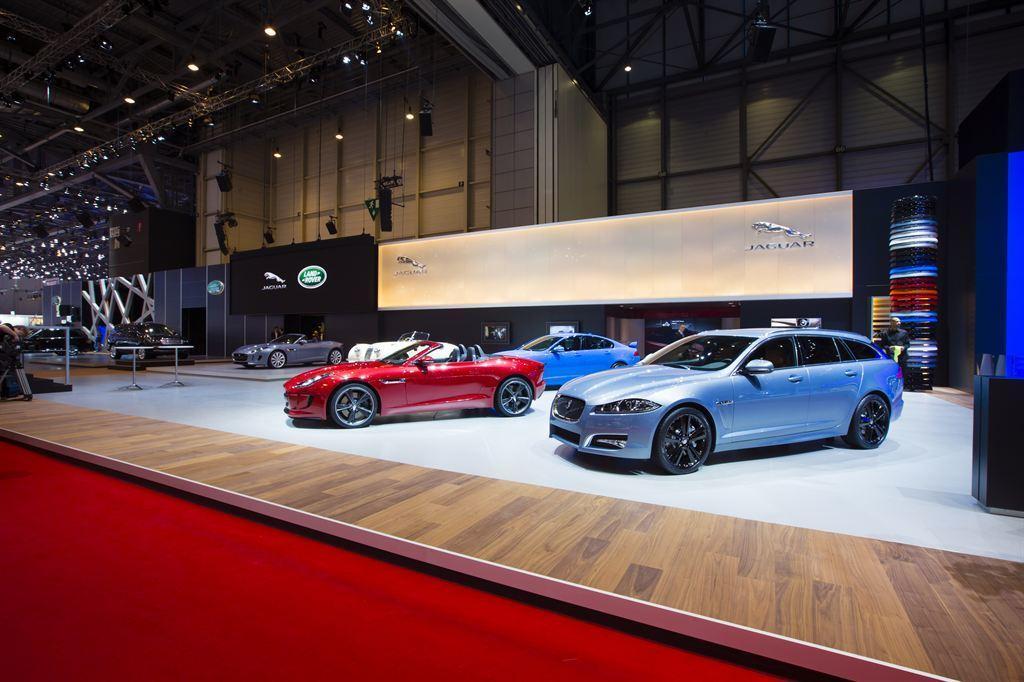Could you give a brief overview of what you see in this image? In the picture I can see vehicles on the floor. I can also see boards which has logo's, tables, lights on the ceiling and some other objects on the floor. 